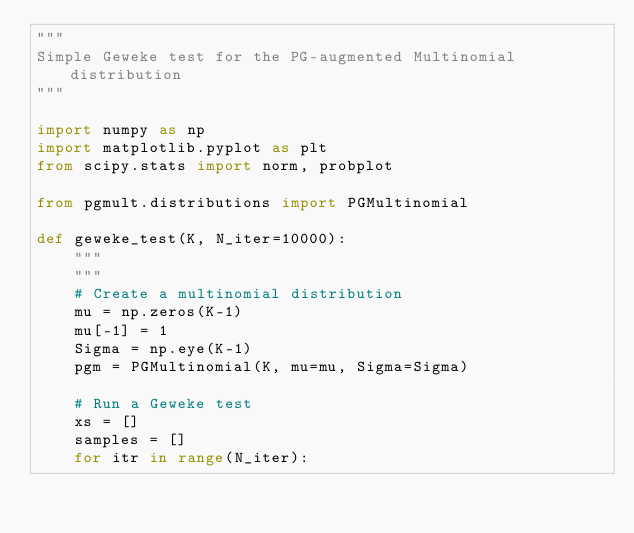Convert code to text. <code><loc_0><loc_0><loc_500><loc_500><_Python_>"""
Simple Geweke test for the PG-augmented Multinomial distribution
"""

import numpy as np
import matplotlib.pyplot as plt
from scipy.stats import norm, probplot

from pgmult.distributions import PGMultinomial

def geweke_test(K, N_iter=10000):
    """
    """
    # Create a multinomial distribution
    mu = np.zeros(K-1)
    mu[-1] = 1
    Sigma = np.eye(K-1)
    pgm = PGMultinomial(K, mu=mu, Sigma=Sigma)

    # Run a Geweke test
    xs = []
    samples = []
    for itr in range(N_iter):</code> 